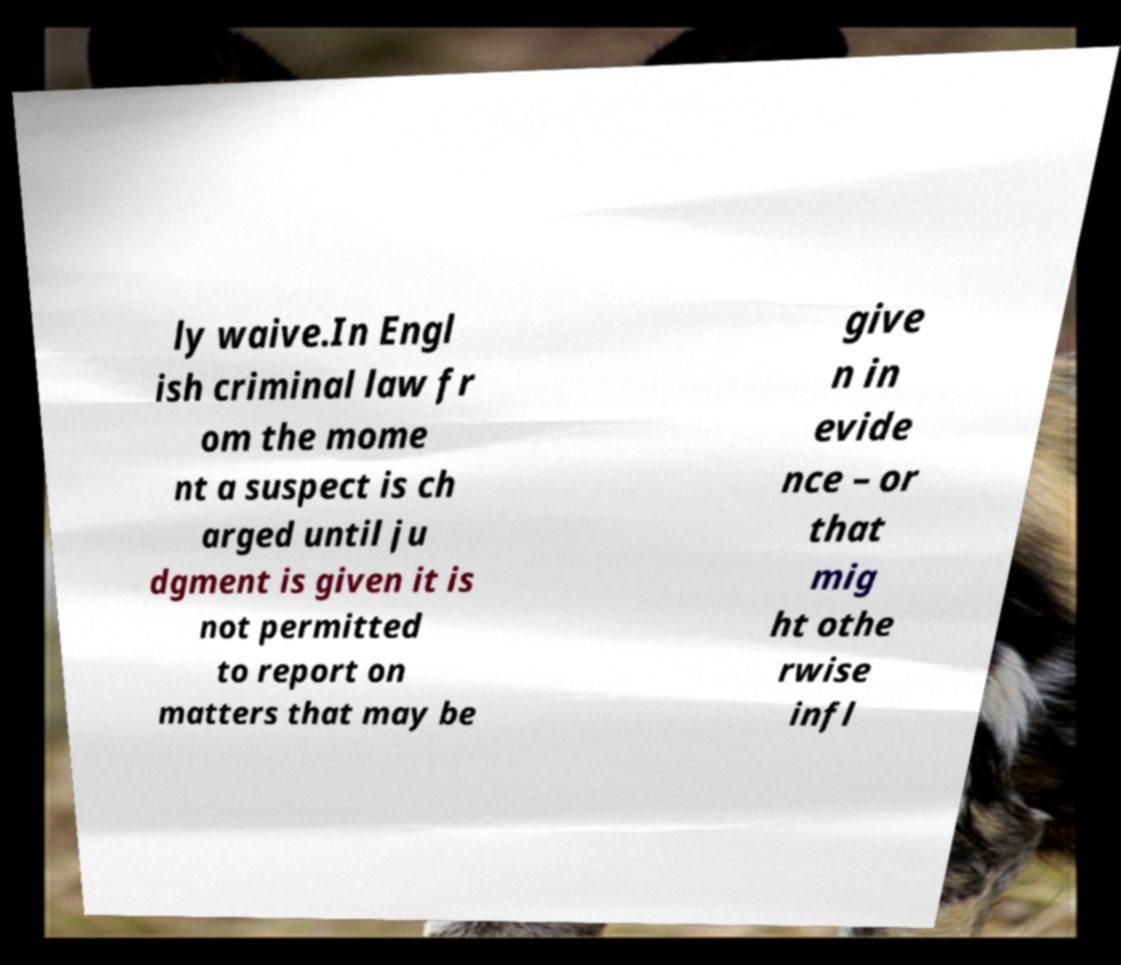Could you extract and type out the text from this image? ly waive.In Engl ish criminal law fr om the mome nt a suspect is ch arged until ju dgment is given it is not permitted to report on matters that may be give n in evide nce – or that mig ht othe rwise infl 